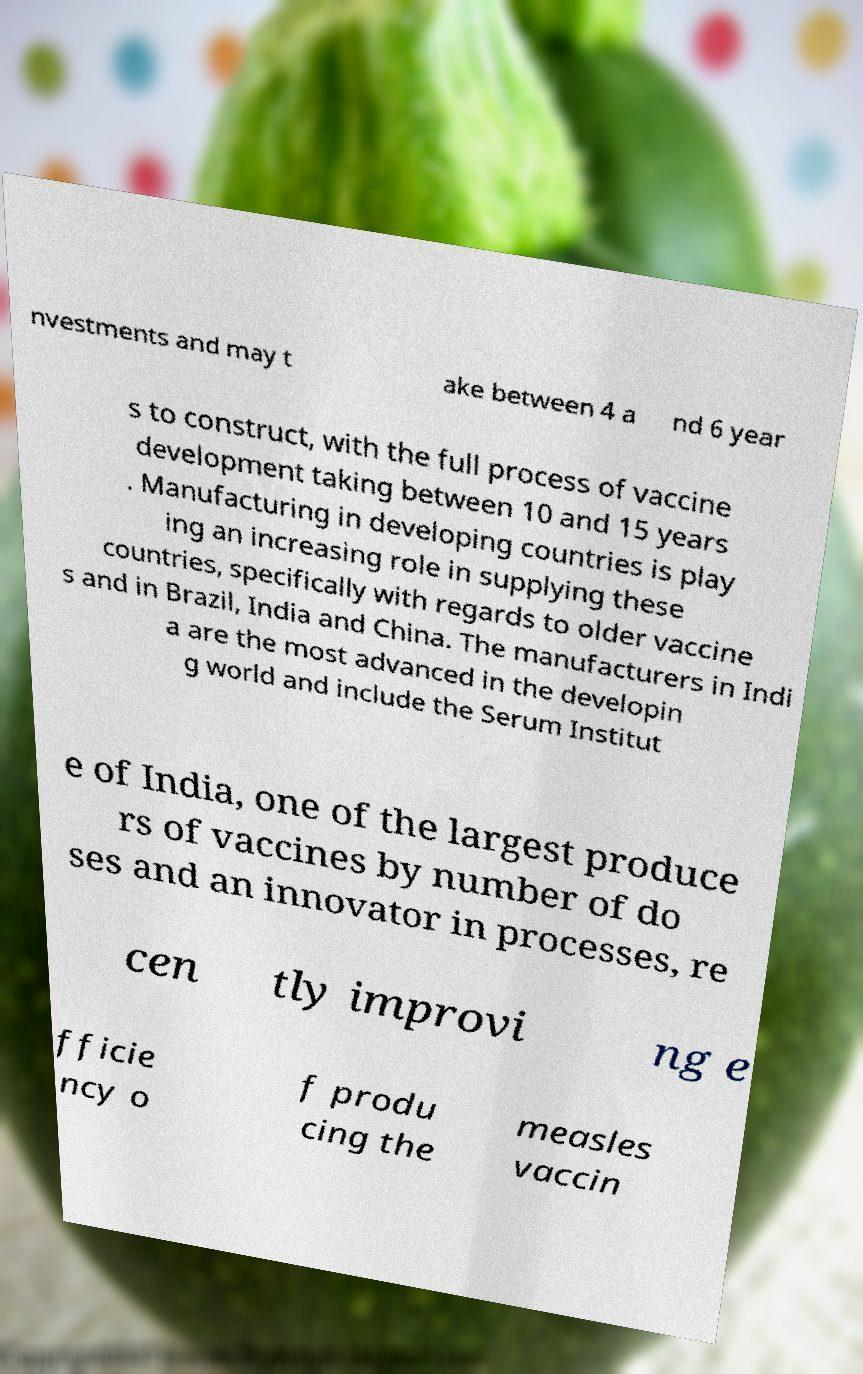Can you accurately transcribe the text from the provided image for me? nvestments and may t ake between 4 a nd 6 year s to construct, with the full process of vaccine development taking between 10 and 15 years . Manufacturing in developing countries is play ing an increasing role in supplying these countries, specifically with regards to older vaccine s and in Brazil, India and China. The manufacturers in Indi a are the most advanced in the developin g world and include the Serum Institut e of India, one of the largest produce rs of vaccines by number of do ses and an innovator in processes, re cen tly improvi ng e fficie ncy o f produ cing the measles vaccin 